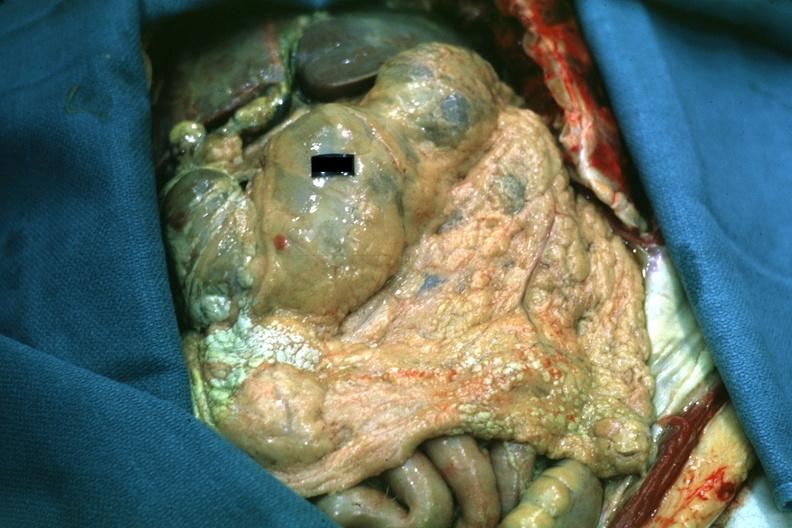what is present?
Answer the question using a single word or phrase. Omentum 